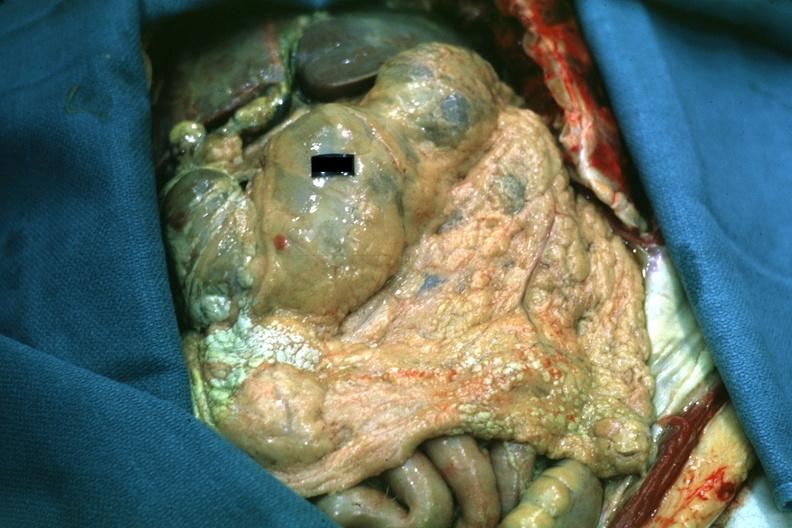what is present?
Answer the question using a single word or phrase. Omentum 